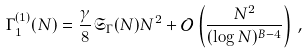<formula> <loc_0><loc_0><loc_500><loc_500>\Gamma _ { 1 } ^ { ( 1 ) } ( N ) = \frac { \gamma } { 8 } \mathfrak { S } _ { \Gamma } ( N ) N ^ { 2 } + \mathcal { O } \left ( \frac { N ^ { 2 } } { ( \log N ) ^ { B - 4 } } \right ) \, ,</formula> 